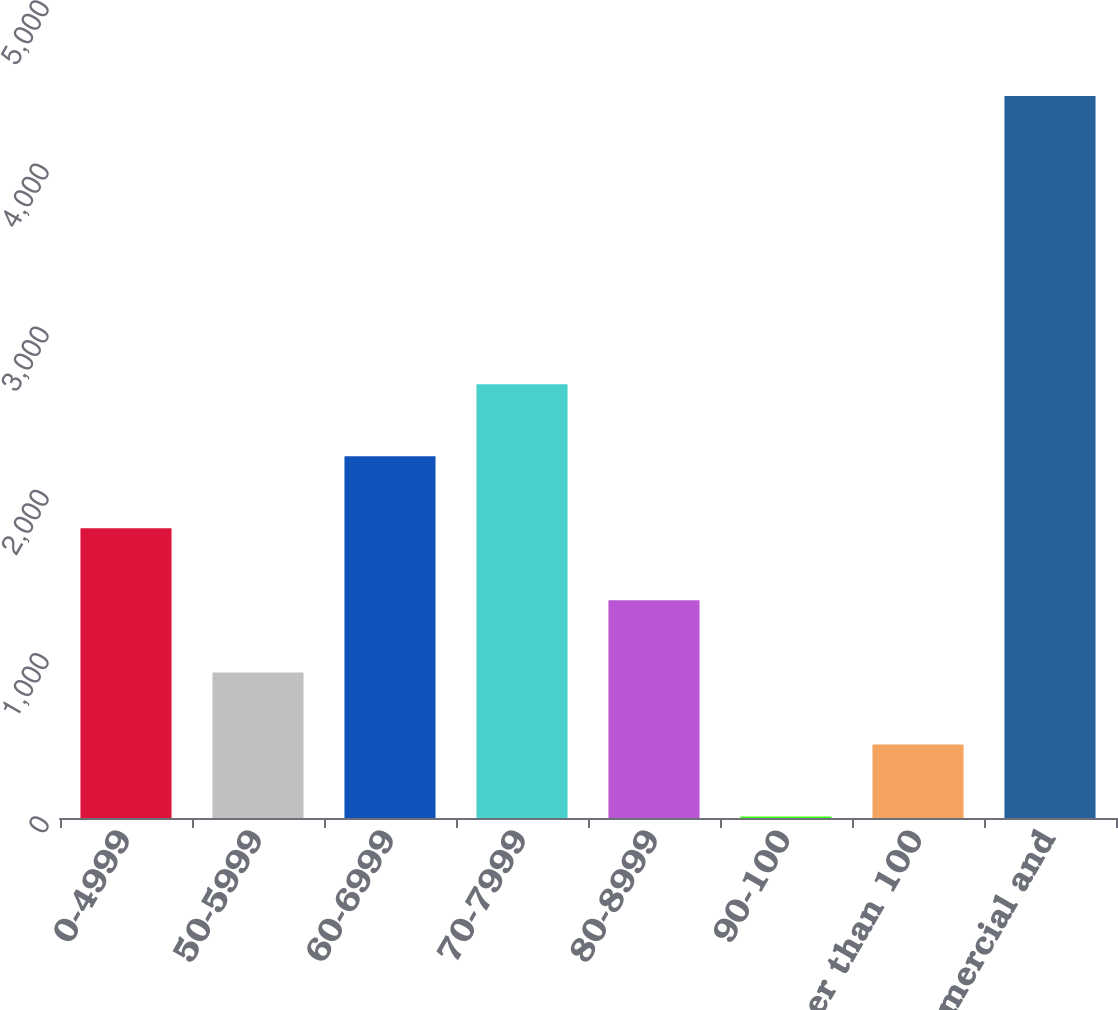<chart> <loc_0><loc_0><loc_500><loc_500><bar_chart><fcel>0-4999<fcel>50-5999<fcel>60-6999<fcel>70-7999<fcel>80-8999<fcel>90-100<fcel>Greater than 100<fcel>Total commercial and<nl><fcel>1775<fcel>892<fcel>2216.5<fcel>2658<fcel>1333.5<fcel>9<fcel>450.5<fcel>4424<nl></chart> 